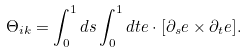Convert formula to latex. <formula><loc_0><loc_0><loc_500><loc_500>\Theta _ { i k } = \int _ { 0 } ^ { 1 } d s \int _ { 0 } ^ { 1 } d t e \cdot [ \partial _ { s } e \times \partial _ { t } e ] .</formula> 